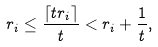Convert formula to latex. <formula><loc_0><loc_0><loc_500><loc_500>r _ { i } \leq \frac { \left \lceil t r _ { i } \right \rceil } { t } < r _ { i } + \frac { 1 } { t } ,</formula> 